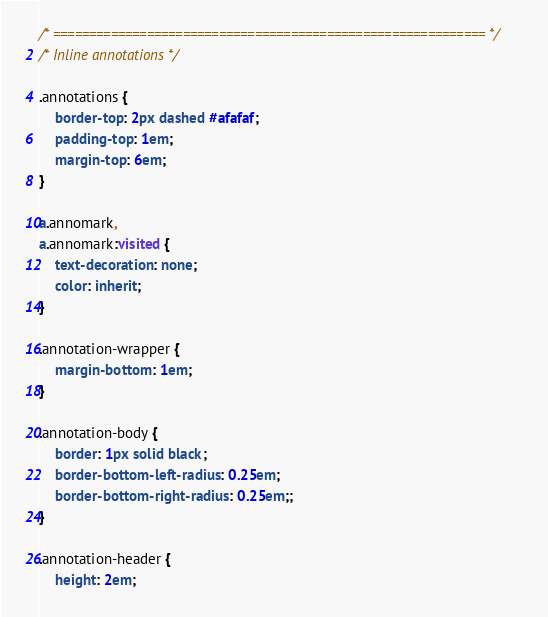Convert code to text. <code><loc_0><loc_0><loc_500><loc_500><_CSS_>/* ============================================================ */
/* Inline annotations */

.annotations {
    border-top: 2px dashed #afafaf;
    padding-top: 1em;
    margin-top: 6em;
}

a.annomark,
a.annomark:visited {
    text-decoration: none;
    color: inherit;
}

.annotation-wrapper {
    margin-bottom: 1em;
}

.annotation-body {
    border: 1px solid black;
    border-bottom-left-radius: 0.25em;
    border-bottom-right-radius: 0.25em;;
}

.annotation-header {
    height: 2em;</code> 